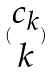<formula> <loc_0><loc_0><loc_500><loc_500>( \begin{matrix} c _ { k } \\ k \end{matrix} )</formula> 